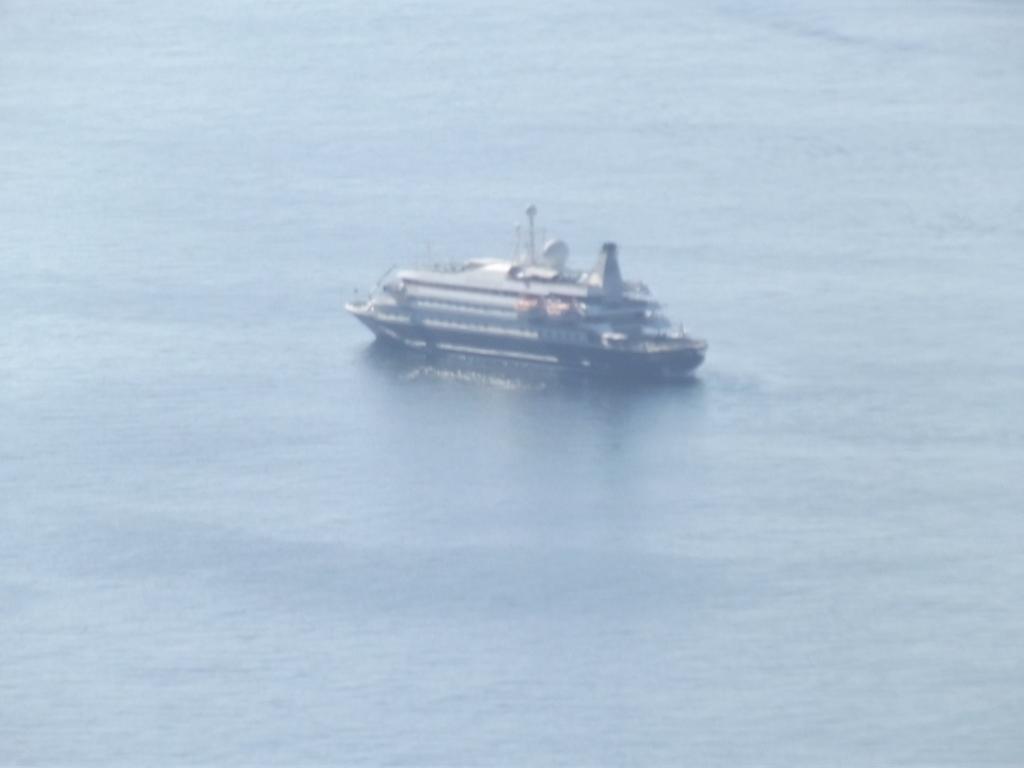Please provide a concise description of this image. In this image we can see water in the water the ship is floating. 